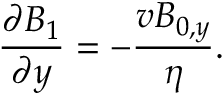<formula> <loc_0><loc_0><loc_500><loc_500>\frac { \partial B _ { 1 } } { \partial y } = - \frac { v B _ { 0 , y } } { \eta } .</formula> 